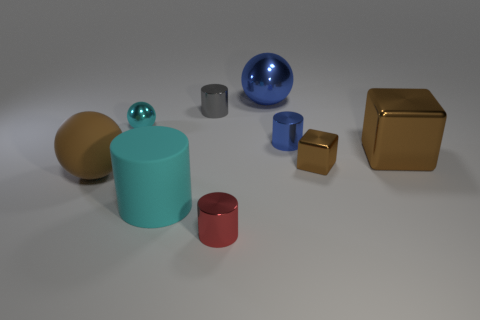Does the big cylinder have the same color as the big block?
Offer a terse response. No. Is the number of tiny gray metallic objects that are to the left of the gray cylinder less than the number of tiny metal cylinders?
Offer a terse response. Yes. There is a object that is the same color as the large rubber cylinder; what material is it?
Offer a very short reply. Metal. Is the material of the red thing the same as the tiny cyan ball?
Offer a terse response. Yes. How many tiny green things are made of the same material as the tiny gray cylinder?
Offer a very short reply. 0. What is the color of the tiny cube that is the same material as the gray object?
Your answer should be very brief. Brown. What is the shape of the small gray object?
Offer a very short reply. Cylinder. What is the big brown thing left of the tiny gray metallic cylinder made of?
Provide a short and direct response. Rubber. Are there any large cubes that have the same color as the big matte cylinder?
Your answer should be very brief. No. The gray thing that is the same size as the blue cylinder is what shape?
Keep it short and to the point. Cylinder. 